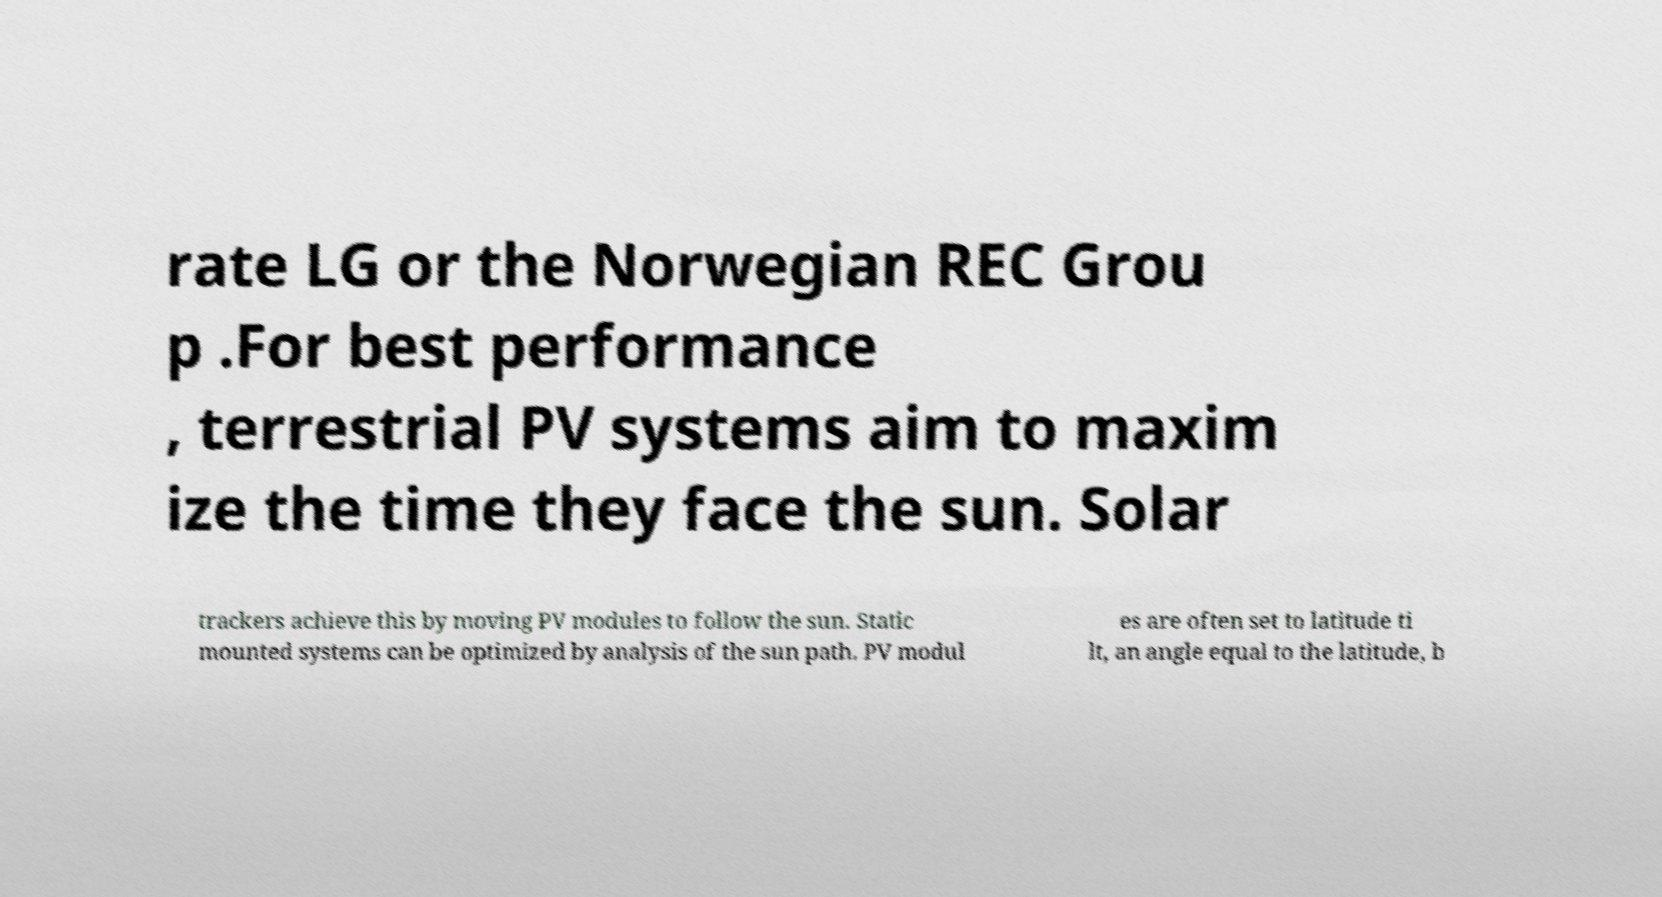For documentation purposes, I need the text within this image transcribed. Could you provide that? rate LG or the Norwegian REC Grou p .For best performance , terrestrial PV systems aim to maxim ize the time they face the sun. Solar trackers achieve this by moving PV modules to follow the sun. Static mounted systems can be optimized by analysis of the sun path. PV modul es are often set to latitude ti lt, an angle equal to the latitude, b 